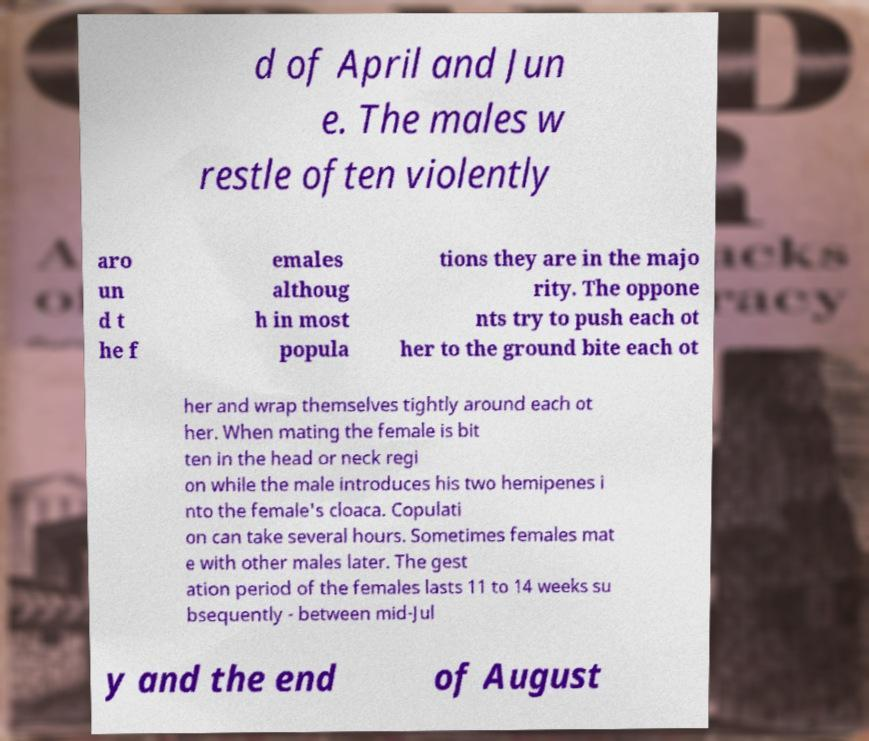Can you accurately transcribe the text from the provided image for me? d of April and Jun e. The males w restle often violently aro un d t he f emales althoug h in most popula tions they are in the majo rity. The oppone nts try to push each ot her to the ground bite each ot her and wrap themselves tightly around each ot her. When mating the female is bit ten in the head or neck regi on while the male introduces his two hemipenes i nto the female's cloaca. Copulati on can take several hours. Sometimes females mat e with other males later. The gest ation period of the females lasts 11 to 14 weeks su bsequently - between mid-Jul y and the end of August 